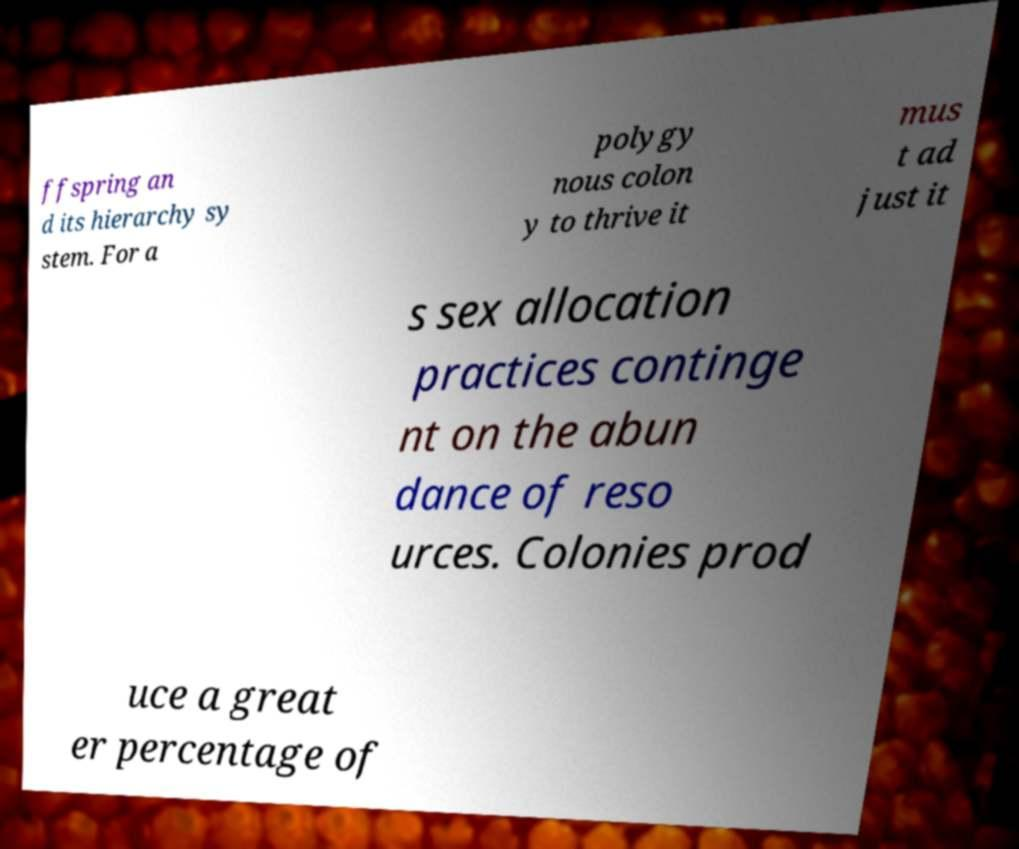I need the written content from this picture converted into text. Can you do that? ffspring an d its hierarchy sy stem. For a polygy nous colon y to thrive it mus t ad just it s sex allocation practices continge nt on the abun dance of reso urces. Colonies prod uce a great er percentage of 